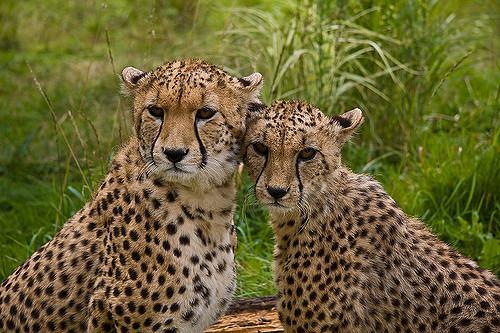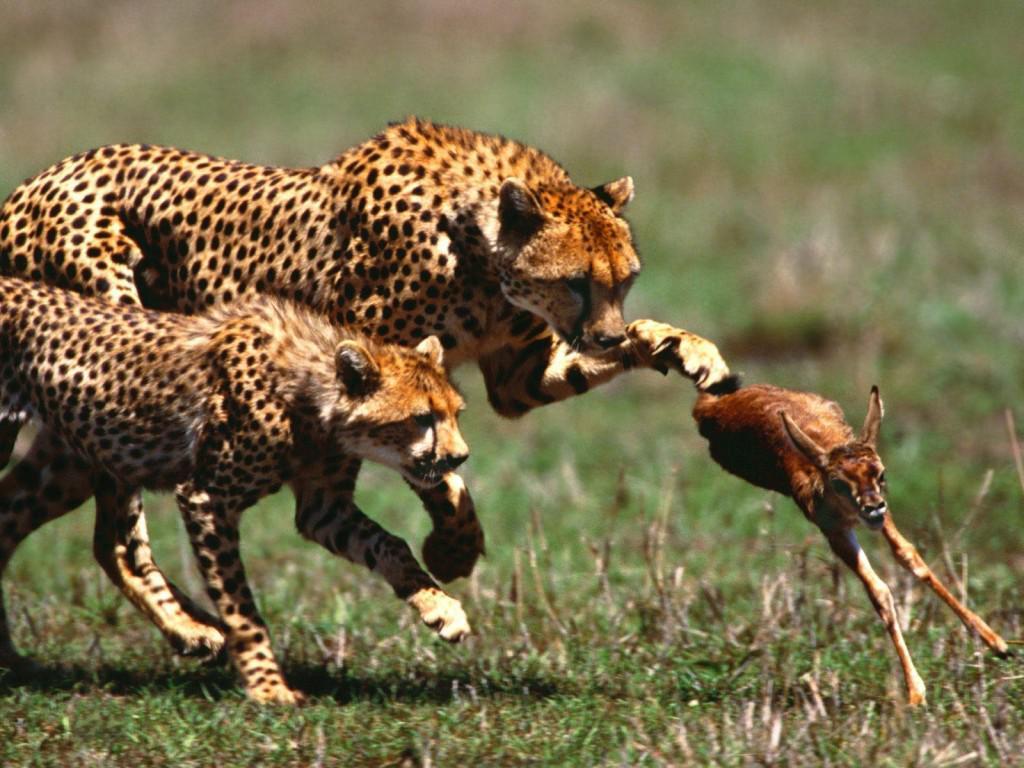The first image is the image on the left, the second image is the image on the right. Analyze the images presented: Is the assertion "There are a pair of cheetahs laying on the grown while one is grooming the other." valid? Answer yes or no. No. The first image is the image on the left, the second image is the image on the right. For the images shown, is this caption "All of the cheetahs are laying down." true? Answer yes or no. No. 